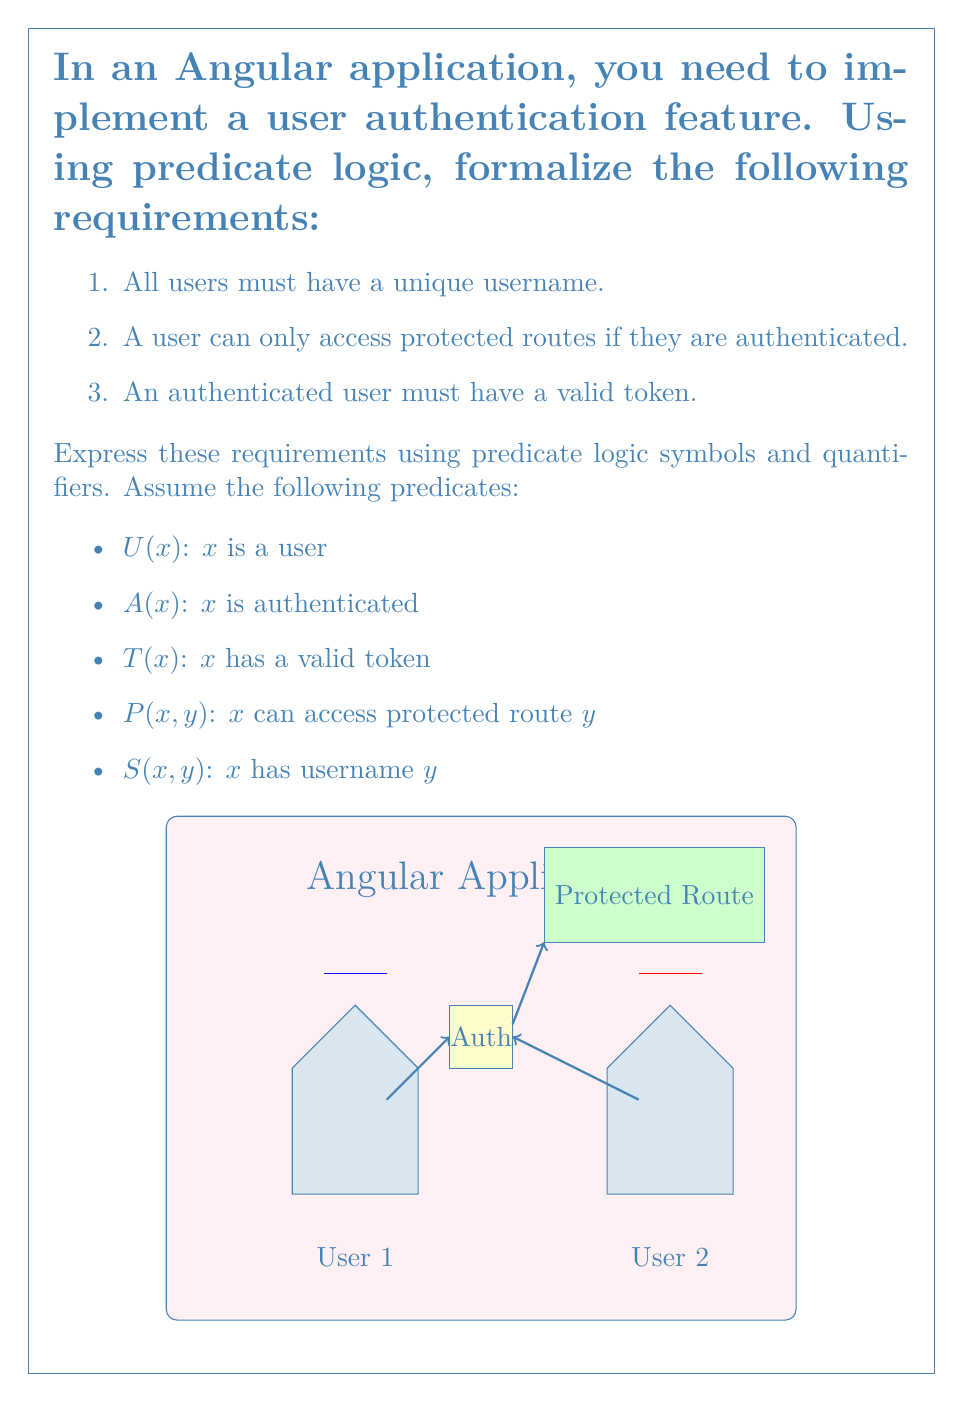Show me your answer to this math problem. Let's formalize each requirement using predicate logic:

1. All users must have a unique username:
   $\forall x \forall y ((U(x) \land U(y) \land S(x, z) \land S(y, z)) \rightarrow x = y)$
   
   This states that for all users $x$ and $y$, if they have the same username $z$, then $x$ and $y$ must be the same user.

2. A user can only access protected routes if they are authenticated:
   $\forall x \forall y ((U(x) \land P(x, y)) \rightarrow A(x))$
   
   This states that for all users $x$ and all protected routes $y$, if $x$ can access $y$, then $x$ must be authenticated.

3. An authenticated user must have a valid token:
   $\forall x (U(x) \land A(x) \rightarrow T(x))$
   
   This states that for all users $x$, if $x$ is authenticated, then $x$ must have a valid token.

Combining these requirements:

$\forall x \forall y \forall z ((U(x) \land U(y) \land S(x, z) \land S(y, z)) \rightarrow x = y) \land$
$\forall x \forall y ((U(x) \land P(x, y)) \rightarrow A(x)) \land$
$\forall x (U(x) \land A(x) \rightarrow T(x))$

This combined statement encapsulates all three requirements in a single predicate logic formula.
Answer: $\forall x \forall y \forall z ((U(x) \land U(y) \land S(x, z) \land S(y, z)) \rightarrow x = y) \land \forall x \forall y ((U(x) \land P(x, y)) \rightarrow A(x)) \land \forall x (U(x) \land A(x) \rightarrow T(x))$ 